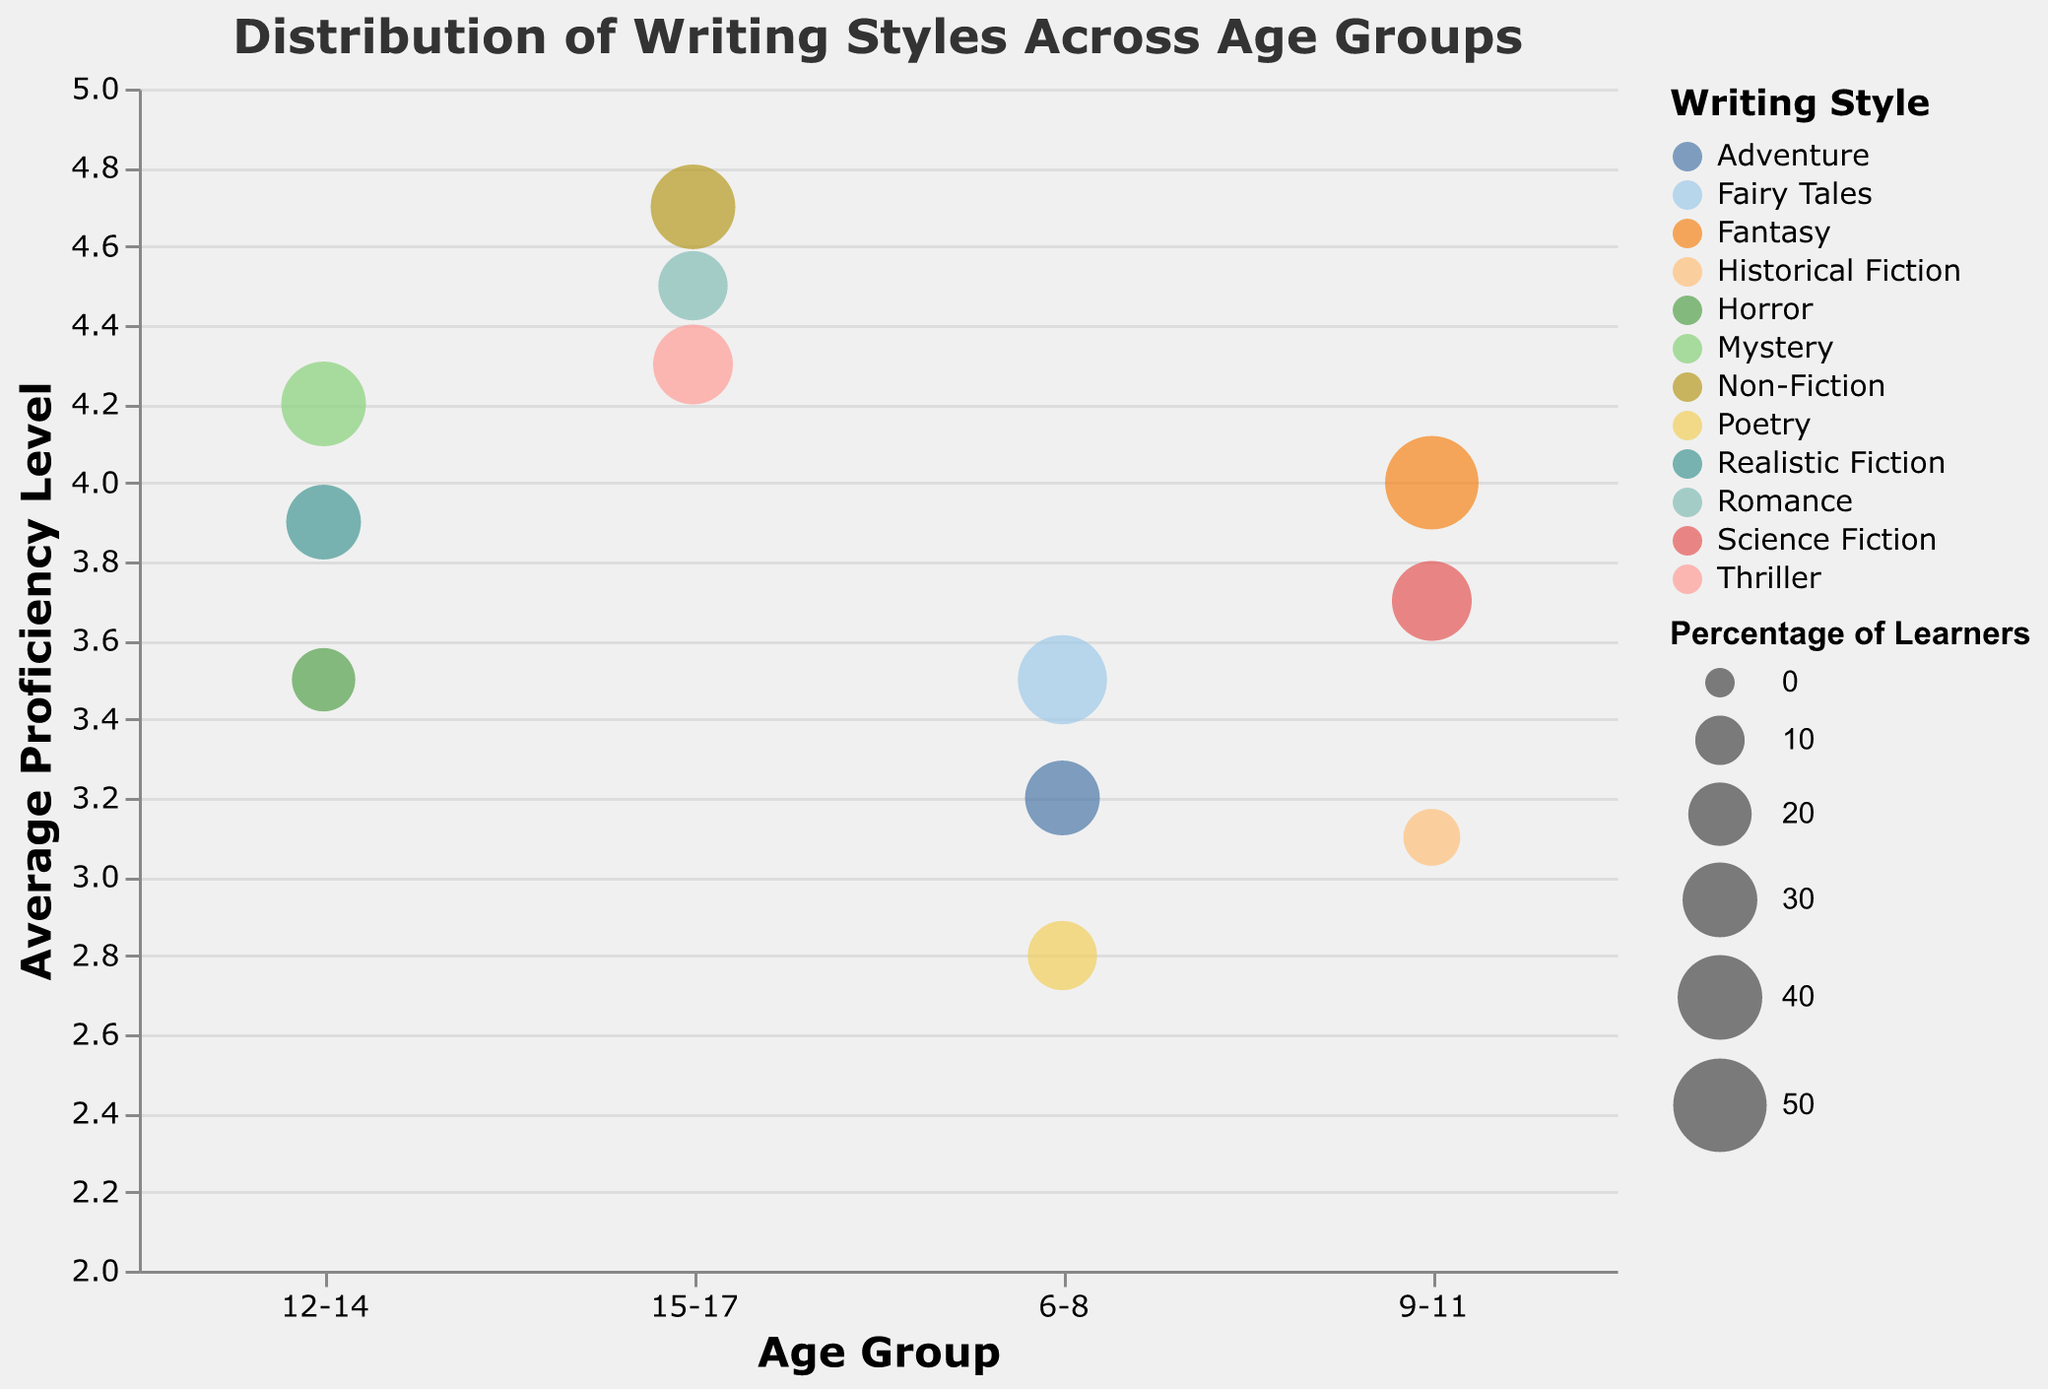What is the writing style with the highest average proficiency level for the 15-17 age group? Locate the proficiency levels for each writing style in the age group 15-17. The highest value is 4.7 for Non-Fiction.
Answer: Non-Fiction Which age group has the largest percentage of learners for Fairy Tales? Check the percentage values for Fairy Tales across the age groups. The highest percentage is 45% in the 6-8 age group.
Answer: 6-8 What is the average proficiency level of Adventure writing for the 6-8 age group? The average proficiency level of Adventure for the 6-8 age group is given as 3.2.
Answer: 3.2 Which writing style in the 9-11 age group has the smallest percentage of learners? In the 9-11 age group, Historical Fiction has the smallest percentage of learners at 15%.
Answer: Historical Fiction How does the average proficiency level of Romance for 15-17 compare to that of Mystery for 12-14? Compare the proficiency levels given for Romance (15-17, 4.5) and Mystery (12-14, 4.2). Romance has a higher average proficiency level.
Answer: Romance What is the total percentage of learners for writing styles in the 12-14 age group? Sum the percentages of learners for the 12-14 age group (40% for Mystery, 30% for Realistic Fiction, and 20% for Horror): 40 + 30 + 20 = 90%.
Answer: 90% Which writing style has the highest average proficiency level? Among all writing styles, Non-Fiction has the highest average proficiency level at 4.7.
Answer: Non-Fiction What is the most popular writing style among learners in the 9-11 age group in terms of percentage? The writing style with the highest percentage in the 9-11 age group is Fantasy at 50%.
Answer: Fantasy Compare the bubble sizes for the Adventure writing style across different age groups. Which age group has the largest bubble size? Adventure is only present in the 6-8 age group with a bubble size of 0.5. Thus, 6-8 has the largest bubble size for Adventure.
Answer: 6-8 